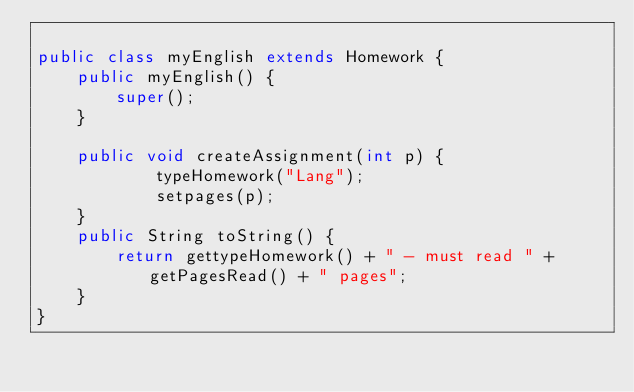Convert code to text. <code><loc_0><loc_0><loc_500><loc_500><_Java_>
public class myEnglish extends Homework {
	public myEnglish() {
		super();	
	}

	public void createAssignment(int p) {
			typeHomework("Lang");
			setpages(p);
	}
	public String toString() {
		return gettypeHomework() + " - must read " + getPagesRead() + " pages";
	}
}
</code> 